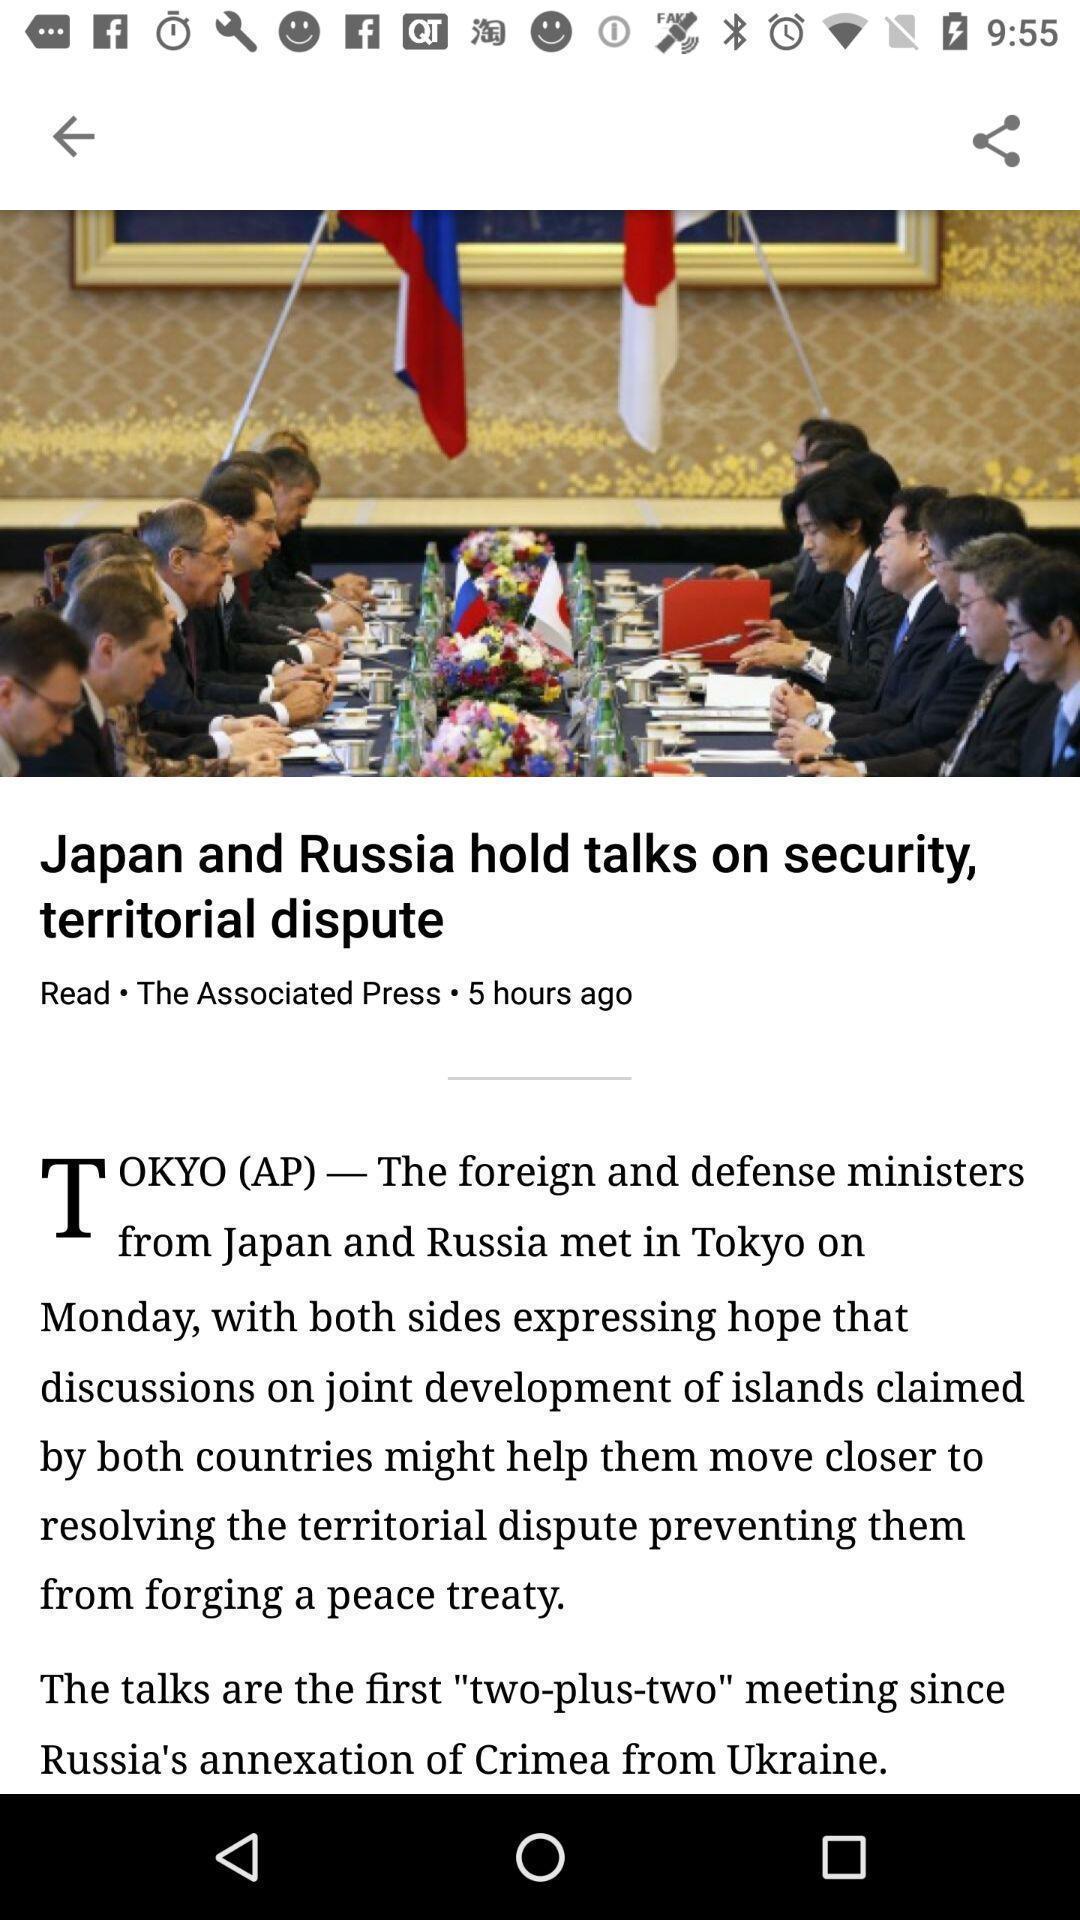Summarize the information in this screenshot. Page showing the details of an article. 